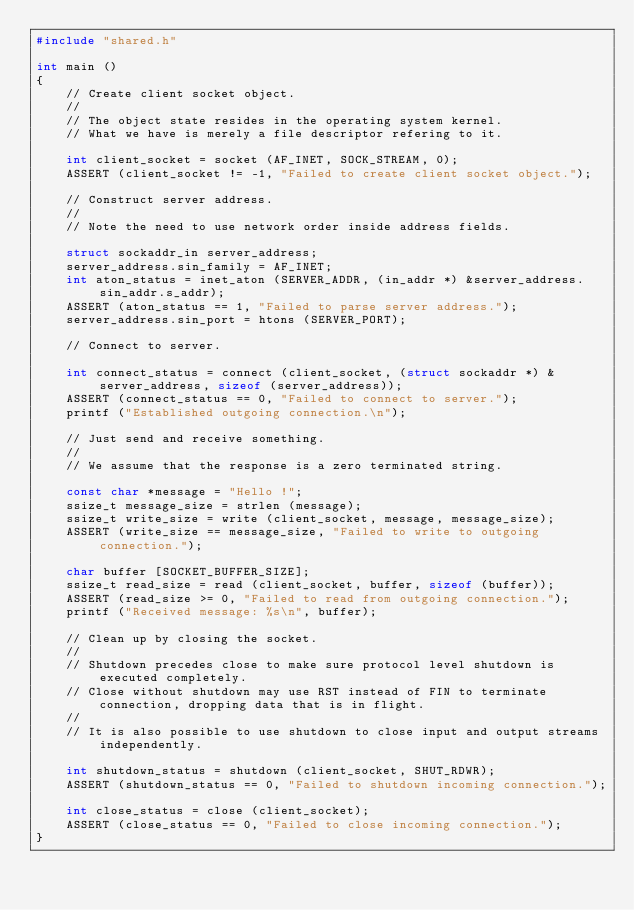Convert code to text. <code><loc_0><loc_0><loc_500><loc_500><_C_>#include "shared.h"

int main ()
{
    // Create client socket object.
    //
    // The object state resides in the operating system kernel.
    // What we have is merely a file descriptor refering to it.

    int client_socket = socket (AF_INET, SOCK_STREAM, 0);
    ASSERT (client_socket != -1, "Failed to create client socket object.");

    // Construct server address.
    //
    // Note the need to use network order inside address fields.

    struct sockaddr_in server_address;
    server_address.sin_family = AF_INET;
    int aton_status = inet_aton (SERVER_ADDR, (in_addr *) &server_address.sin_addr.s_addr);
    ASSERT (aton_status == 1, "Failed to parse server address.");
    server_address.sin_port = htons (SERVER_PORT);

    // Connect to server.

    int connect_status = connect (client_socket, (struct sockaddr *) &server_address, sizeof (server_address));
    ASSERT (connect_status == 0, "Failed to connect to server.");
    printf ("Established outgoing connection.\n");

    // Just send and receive something.
    //
    // We assume that the response is a zero terminated string.

    const char *message = "Hello !";
    ssize_t message_size = strlen (message);
    ssize_t write_size = write (client_socket, message, message_size);
    ASSERT (write_size == message_size, "Failed to write to outgoing connection.");

    char buffer [SOCKET_BUFFER_SIZE];
    ssize_t read_size = read (client_socket, buffer, sizeof (buffer));
    ASSERT (read_size >= 0, "Failed to read from outgoing connection.");
    printf ("Received message: %s\n", buffer);

    // Clean up by closing the socket.
    //
    // Shutdown precedes close to make sure protocol level shutdown is executed completely.
    // Close without shutdown may use RST instead of FIN to terminate connection, dropping data that is in flight.
    //
    // It is also possible to use shutdown to close input and output streams independently.

    int shutdown_status = shutdown (client_socket, SHUT_RDWR);
    ASSERT (shutdown_status == 0, "Failed to shutdown incoming connection.");

    int close_status = close (client_socket);
    ASSERT (close_status == 0, "Failed to close incoming connection.");
}
</code> 